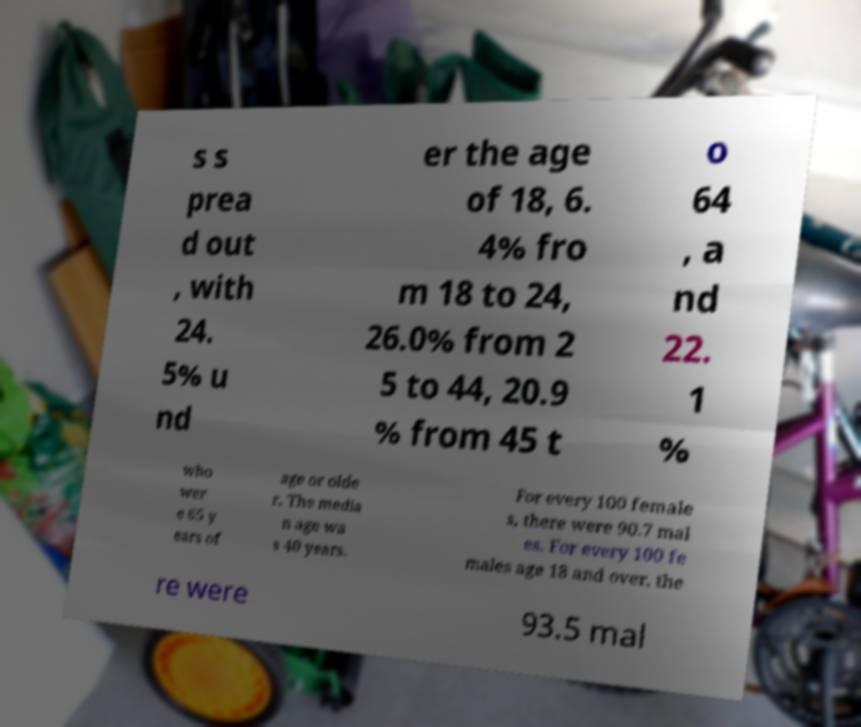Could you extract and type out the text from this image? s s prea d out , with 24. 5% u nd er the age of 18, 6. 4% fro m 18 to 24, 26.0% from 2 5 to 44, 20.9 % from 45 t o 64 , a nd 22. 1 % who wer e 65 y ears of age or olde r. The media n age wa s 40 years. For every 100 female s, there were 90.7 mal es. For every 100 fe males age 18 and over, the re were 93.5 mal 